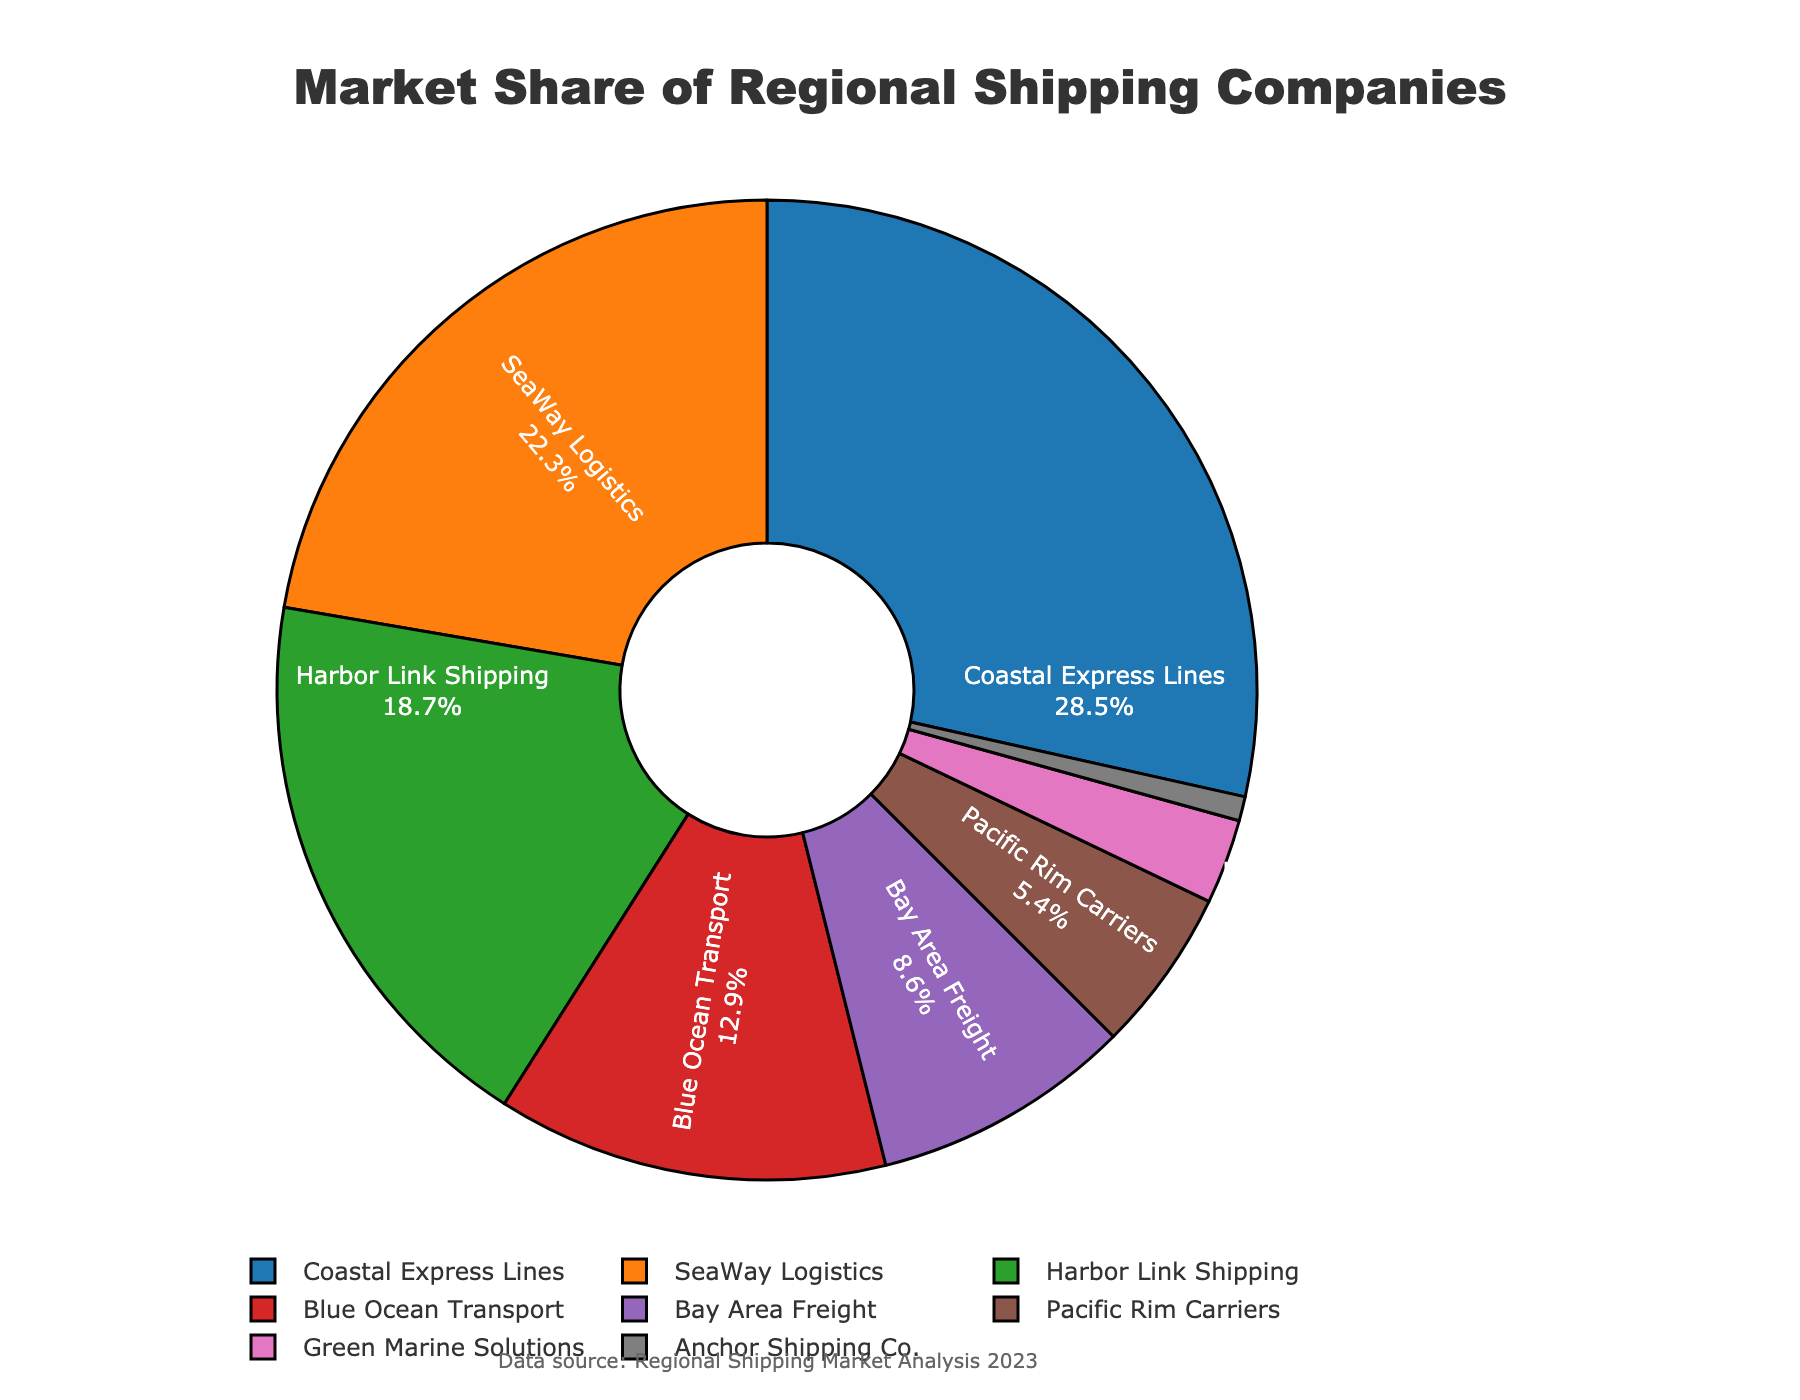What is the largest market share held by a single company? The largest market share can be identified by looking at the pie chart and finding the sector that occupies the most space. The company with the largest market share is Coastal Express Lines with 28.5%.
Answer: 28.5% Which two companies together account for approximately half of the market share? Adding the market shares of the two largest companies, Coastal Express Lines (28.5%) and SeaWay Logistics (22.3%), gives a total of 28.5% + 22.3% = 50.8%, which is approximately half of the market share.
Answer: Coastal Express Lines and SeaWay Logistics How much more market share does Coastal Express Lines have compared to Harbor Link Shipping? Subtract the market share of Harbor Link Shipping (18.7%) from that of Coastal Express Lines (28.5%). The difference is 28.5% - 18.7% = 9.8%.
Answer: 9.8% Which company has the smallest market share, and what is it? The pie chart shows each company's market share. The company with the smallest share is Anchor Shipping Co. with a market share of 0.8%.
Answer: Anchor Shipping Co., 0.8% How many companies have a market share greater than 10%? Count the number of sectors in the pie chart where the market share is greater than 10%. These companies are Coastal Express Lines (28.5%), SeaWay Logistics (22.3%), Harbor Link Shipping (18.7%), and Blue Ocean Transport (12.9%). There are 4 companies in total.
Answer: 4 What is the combined market share of Blue Ocean Transport and Bay Area Freight? Add the market shares of Blue Ocean Transport (12.9%) and Bay Area Freight (8.6%). The combined market share is 12.9% + 8.6% = 21.5%.
Answer: 21.5% Which company has a larger market share: Pacific Rim Carriers or Green Marine Solutions? Comparing the two market shares from the pie chart, Pacific Rim Carriers has a market share of 5.4%, while Green Marine Solutions has a market share of 2.8%. Therefore, Pacific Rim Carriers has a larger market share.
Answer: Pacific Rim Carriers What is the ratio of the market share of Coastal Express Lines to Blue Ocean Transport? Divide the market share of Coastal Express Lines (28.5%) by the market share of Blue Ocean Transport (12.9%). The ratio is 28.5 / 12.9 ≈ 2.21.
Answer: 2.21 What percentage of the market do companies with less than 5% share account for? Add the market shares of companies with less than 5%: Pacific Rim Carriers (5.4% is just above 5%), Green Marine Solutions (2.8%), and Anchor Shipping Co. (0.8%). The total is 2.8% + 0.8% = 3.6%.
Answer: 3.6% Which company occupies the second largest segment in the pie chart? The second largest market share is held by SeaWay Logistics at 22.3%, which is the next largest after Coastal Express Lines.
Answer: SeaWay Logistics 